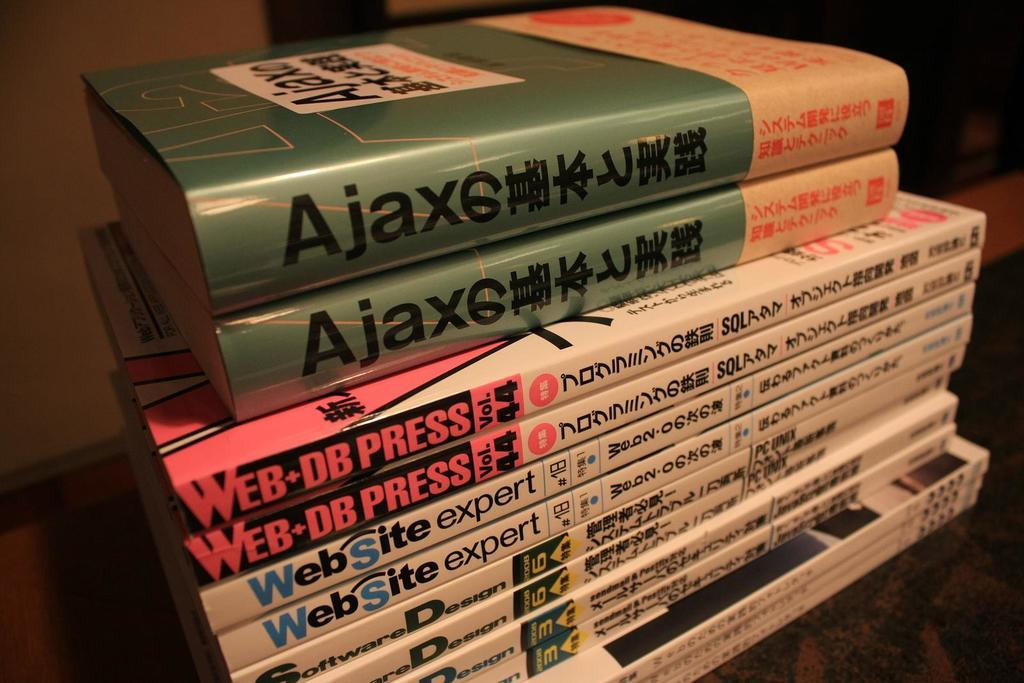<image>
Offer a succinct explanation of the picture presented. A stack of books including Ajax6 and WebSite expert. 